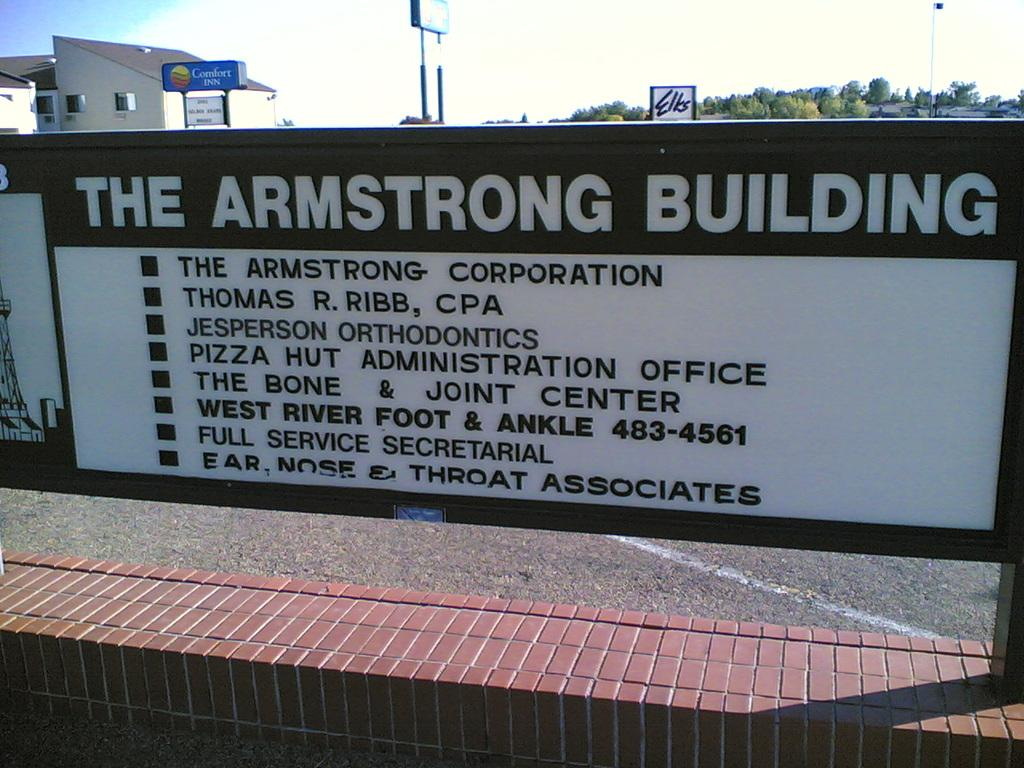<image>
Provide a brief description of the given image. A signboard for The Armstrong Building lists all the different businesses starting with The Armstrong Corporation. 